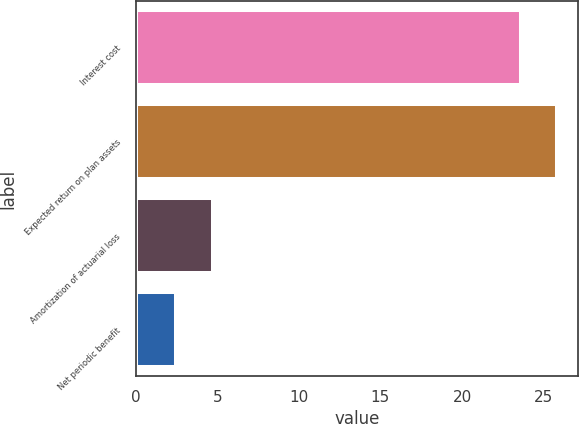Convert chart to OTSL. <chart><loc_0><loc_0><loc_500><loc_500><bar_chart><fcel>Interest cost<fcel>Expected return on plan assets<fcel>Amortization of actuarial loss<fcel>Net periodic benefit<nl><fcel>23.6<fcel>25.82<fcel>4.72<fcel>2.5<nl></chart> 